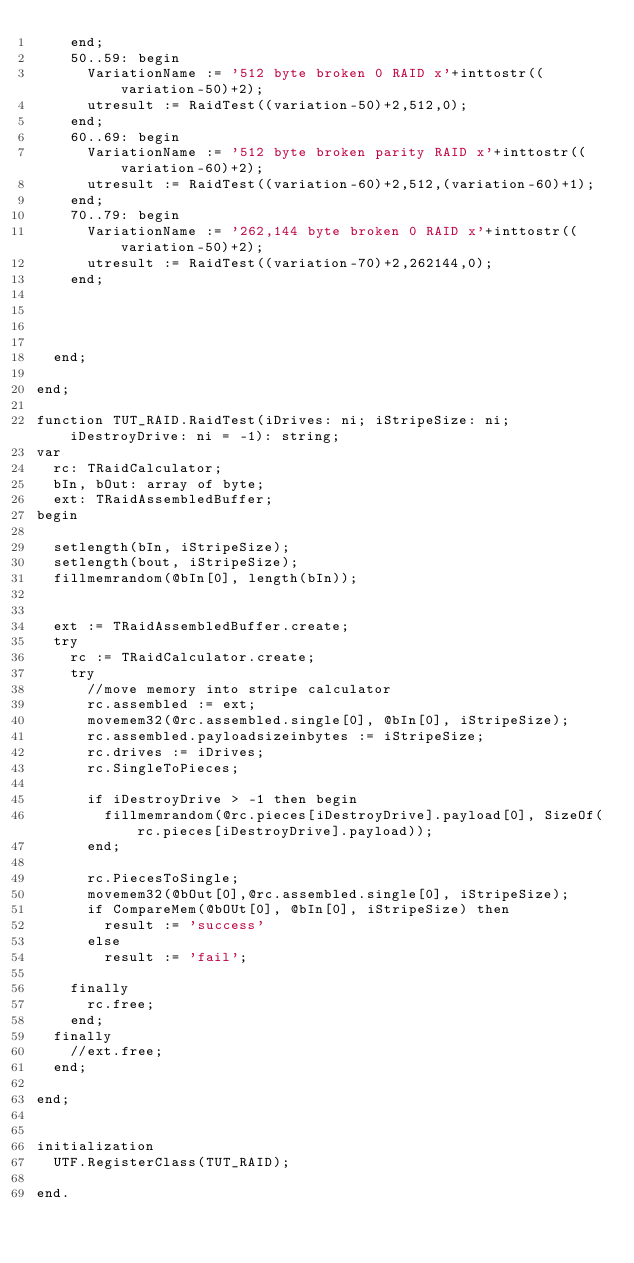<code> <loc_0><loc_0><loc_500><loc_500><_Pascal_>    end;
    50..59: begin
      VariationName := '512 byte broken 0 RAID x'+inttostr((variation-50)+2);
      utresult := RaidTest((variation-50)+2,512,0);
    end;
    60..69: begin
      VariationName := '512 byte broken parity RAID x'+inttostr((variation-60)+2);
      utresult := RaidTest((variation-60)+2,512,(variation-60)+1);
    end;
    70..79: begin
      VariationName := '262,144 byte broken 0 RAID x'+inttostr((variation-50)+2);
      utresult := RaidTest((variation-70)+2,262144,0);
    end;




  end;

end;

function TUT_RAID.RaidTest(iDrives: ni; iStripeSize: ni; iDestroyDrive: ni = -1): string;
var
  rc: TRaidCalculator;
  bIn, bOut: array of byte;
  ext: TRaidAssembledBuffer;
begin

  setlength(bIn, iStripeSize);
  setlength(bout, iStripeSize);
  fillmemrandom(@bIn[0], length(bIn));


  ext := TRaidAssembledBuffer.create;
  try
    rc := TRaidCalculator.create;
    try
      //move memory into stripe calculator
      rc.assembled := ext;
      movemem32(@rc.assembled.single[0], @bIn[0], iStripeSize);
      rc.assembled.payloadsizeinbytes := iStripeSize;
      rc.drives := iDrives;
      rc.SingleToPieces;

      if iDestroyDrive > -1 then begin
        fillmemrandom(@rc.pieces[iDestroyDrive].payload[0], SizeOf(rc.pieces[iDestroyDrive].payload));
      end;

      rc.PiecesToSingle;
      movemem32(@bOut[0],@rc.assembled.single[0], iStripeSize);
      if CompareMem(@bOUt[0], @bIn[0], iStripeSize) then
        result := 'success'
      else
        result := 'fail';

    finally
      rc.free;
    end;
  finally
    //ext.free;
  end;

end;


initialization
  UTF.RegisterClass(TUT_RAID);

end.
</code> 